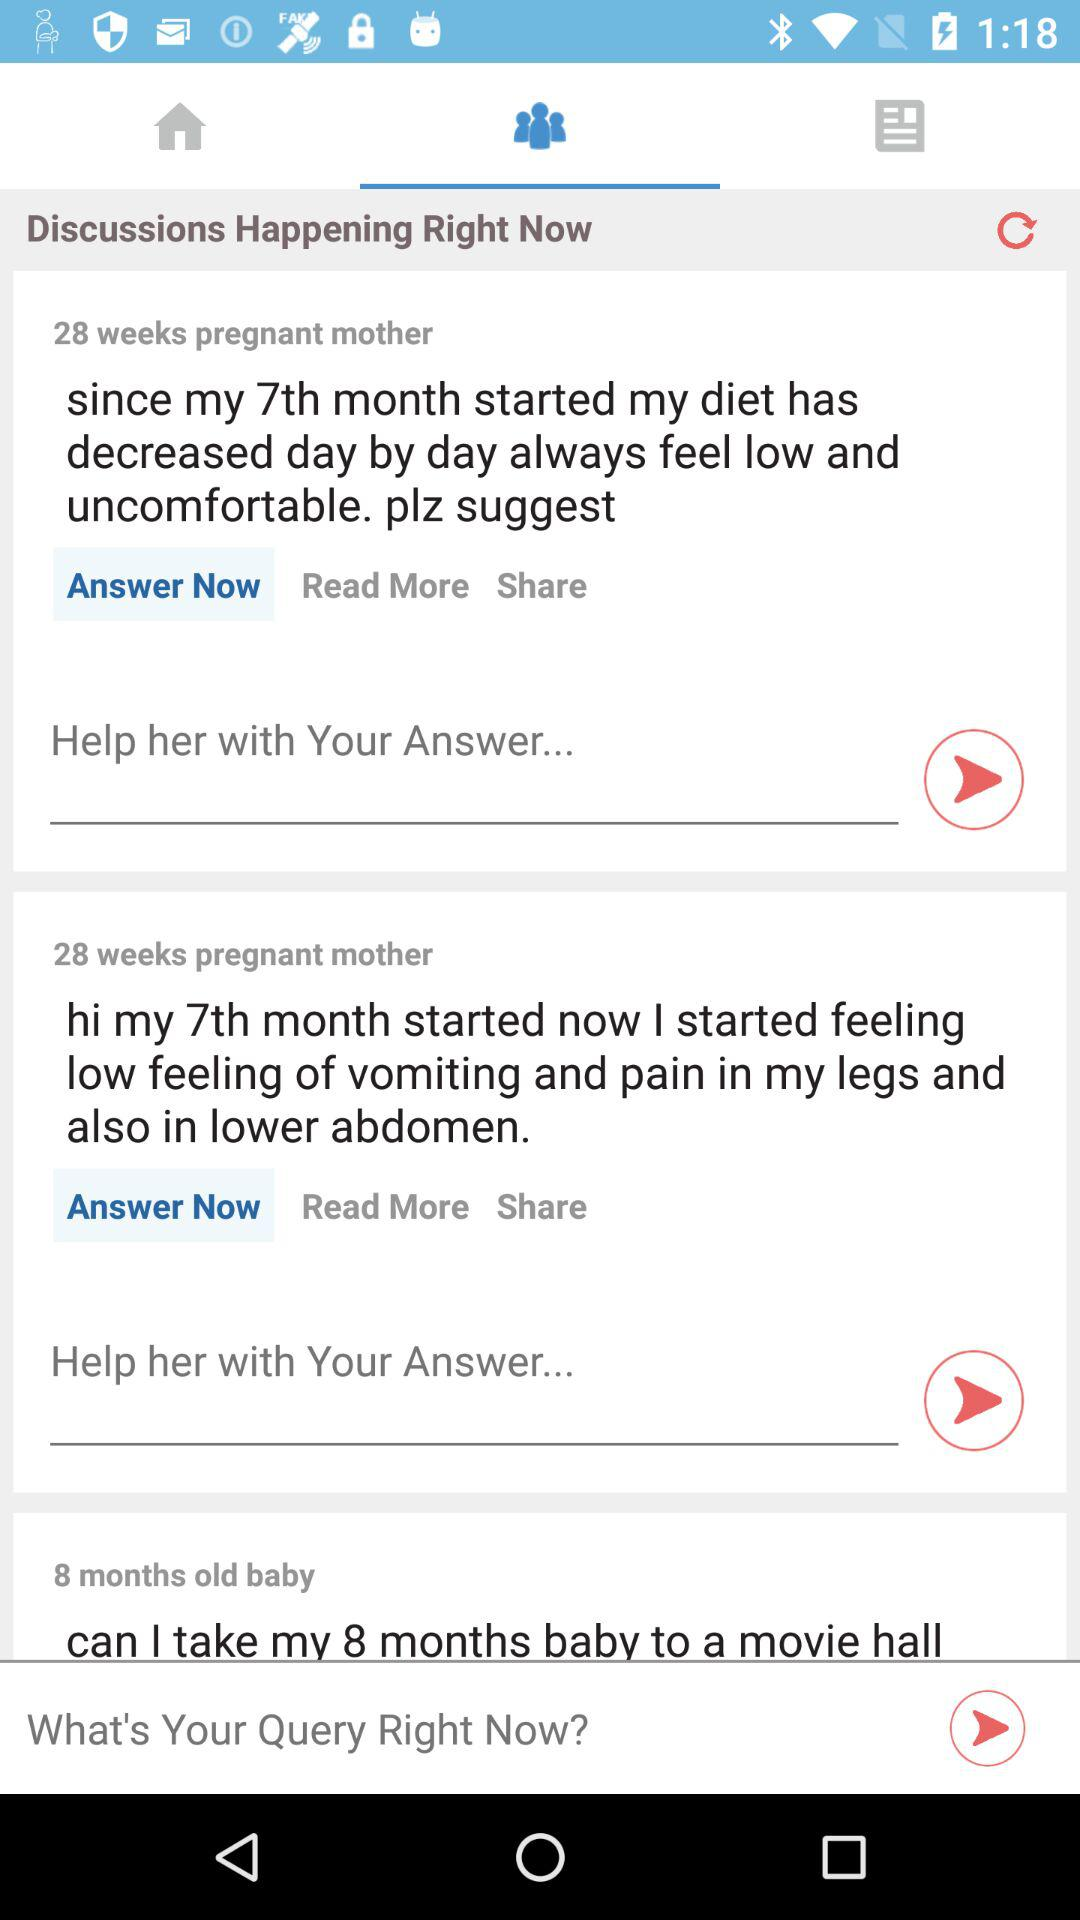What is the mother's pregnancy time? The mother's pregnancy time is 28 weeks. 